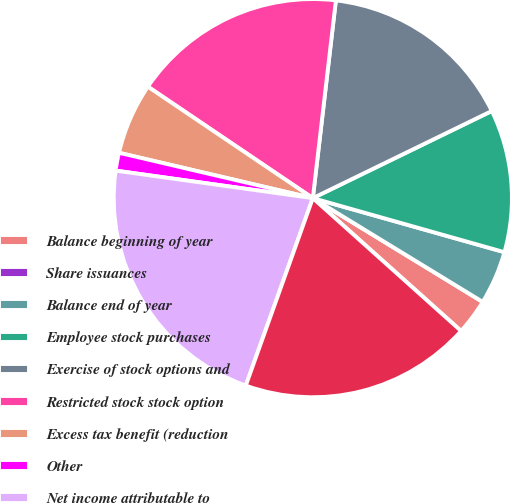Convert chart to OTSL. <chart><loc_0><loc_0><loc_500><loc_500><pie_chart><fcel>Balance beginning of year<fcel>Share issuances<fcel>Balance end of year<fcel>Employee stock purchases<fcel>Exercise of stock options and<fcel>Restricted stock stock option<fcel>Excess tax benefit (reduction<fcel>Other<fcel>Net income attributable to<fcel>Cash dividends declared<nl><fcel>2.9%<fcel>0.0%<fcel>4.35%<fcel>11.59%<fcel>15.94%<fcel>17.39%<fcel>5.8%<fcel>1.45%<fcel>21.74%<fcel>18.84%<nl></chart> 